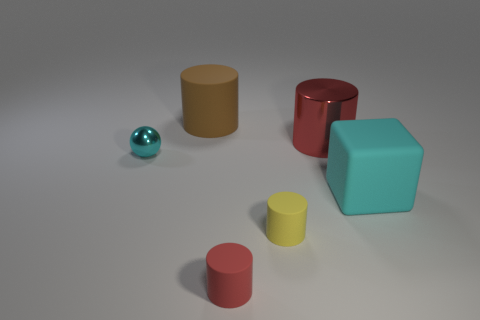Add 2 big blue metallic things. How many objects exist? 8 Subtract all purple cylinders. Subtract all green blocks. How many cylinders are left? 4 Subtract all balls. How many objects are left? 5 Subtract all large brown cylinders. Subtract all tiny cyan things. How many objects are left? 4 Add 6 tiny cyan metallic balls. How many tiny cyan metallic balls are left? 7 Add 4 cyan spheres. How many cyan spheres exist? 5 Subtract 0 blue cylinders. How many objects are left? 6 